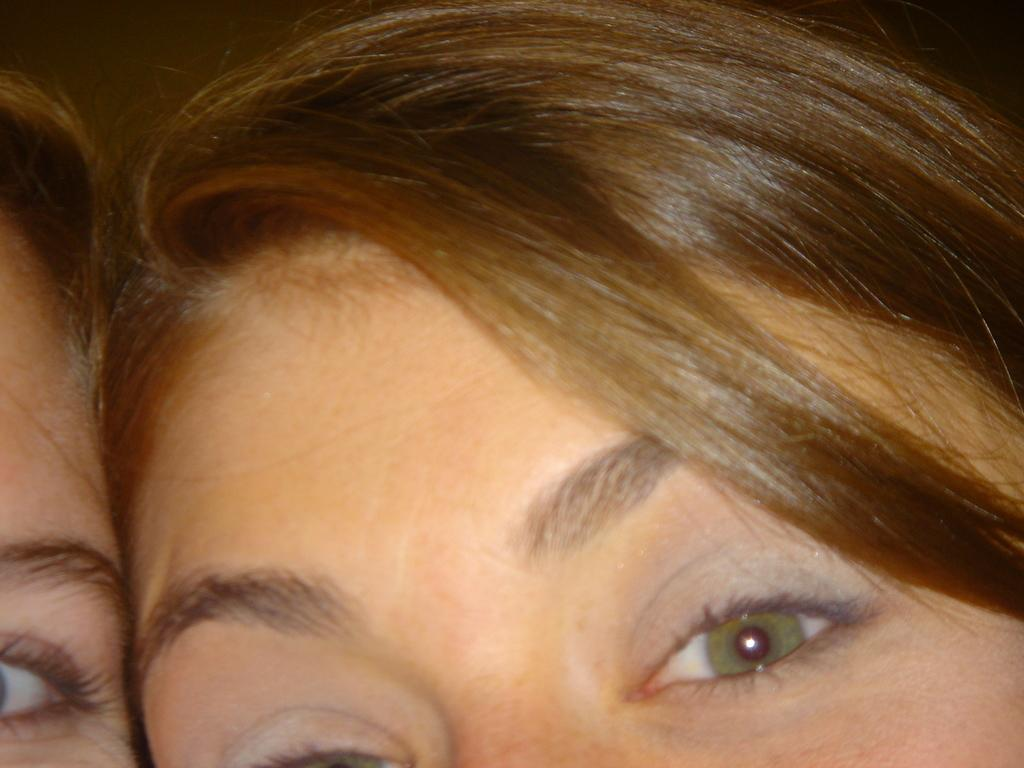How many people are in the image? There are two people in the image. What part of the people's bodies can be seen in the image? Only the heads of the two people are visible in the image. What type of kettle is sitting on the underwear in the image? There is no kettle or underwear present in the image; it only features the heads of two people. 